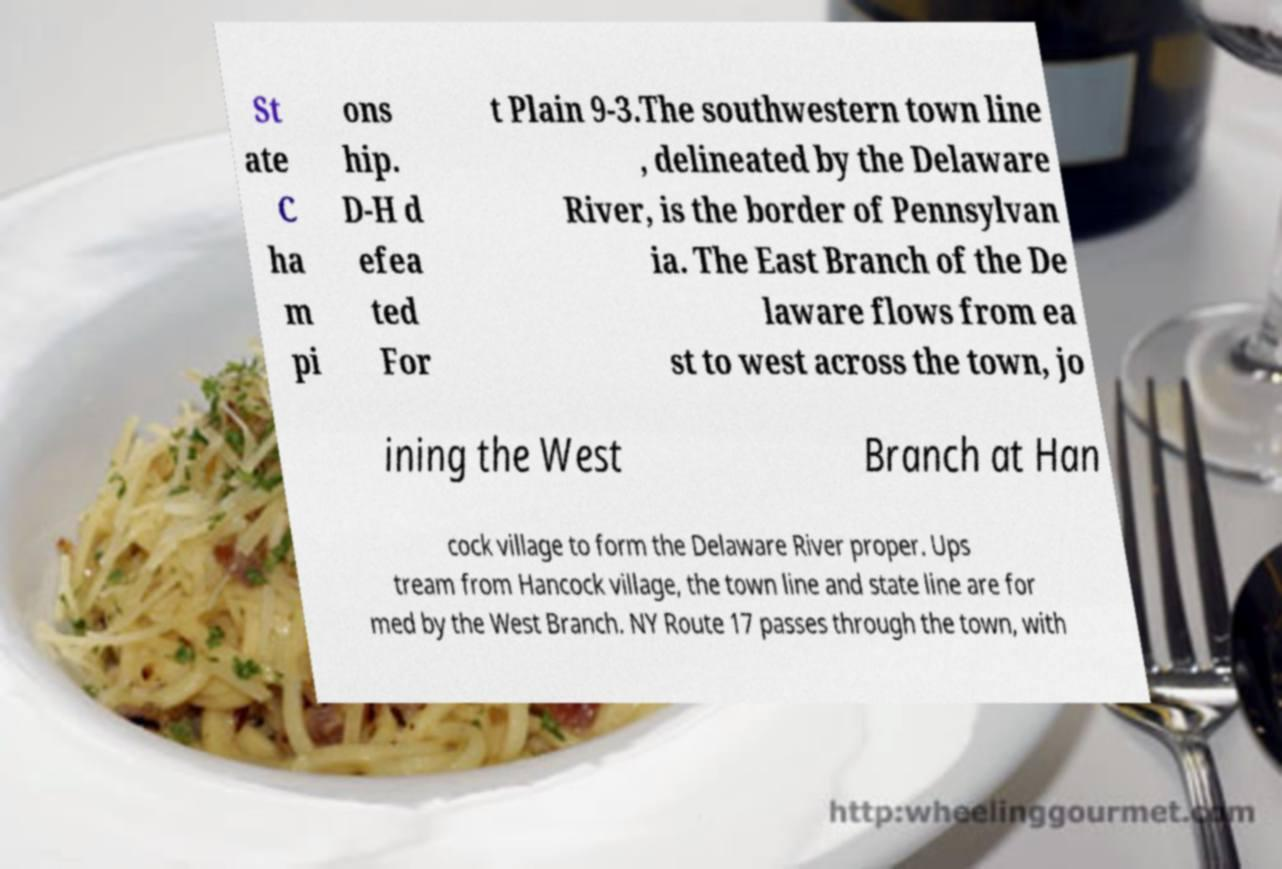Please identify and transcribe the text found in this image. St ate C ha m pi ons hip. D-H d efea ted For t Plain 9-3.The southwestern town line , delineated by the Delaware River, is the border of Pennsylvan ia. The East Branch of the De laware flows from ea st to west across the town, jo ining the West Branch at Han cock village to form the Delaware River proper. Ups tream from Hancock village, the town line and state line are for med by the West Branch. NY Route 17 passes through the town, with 